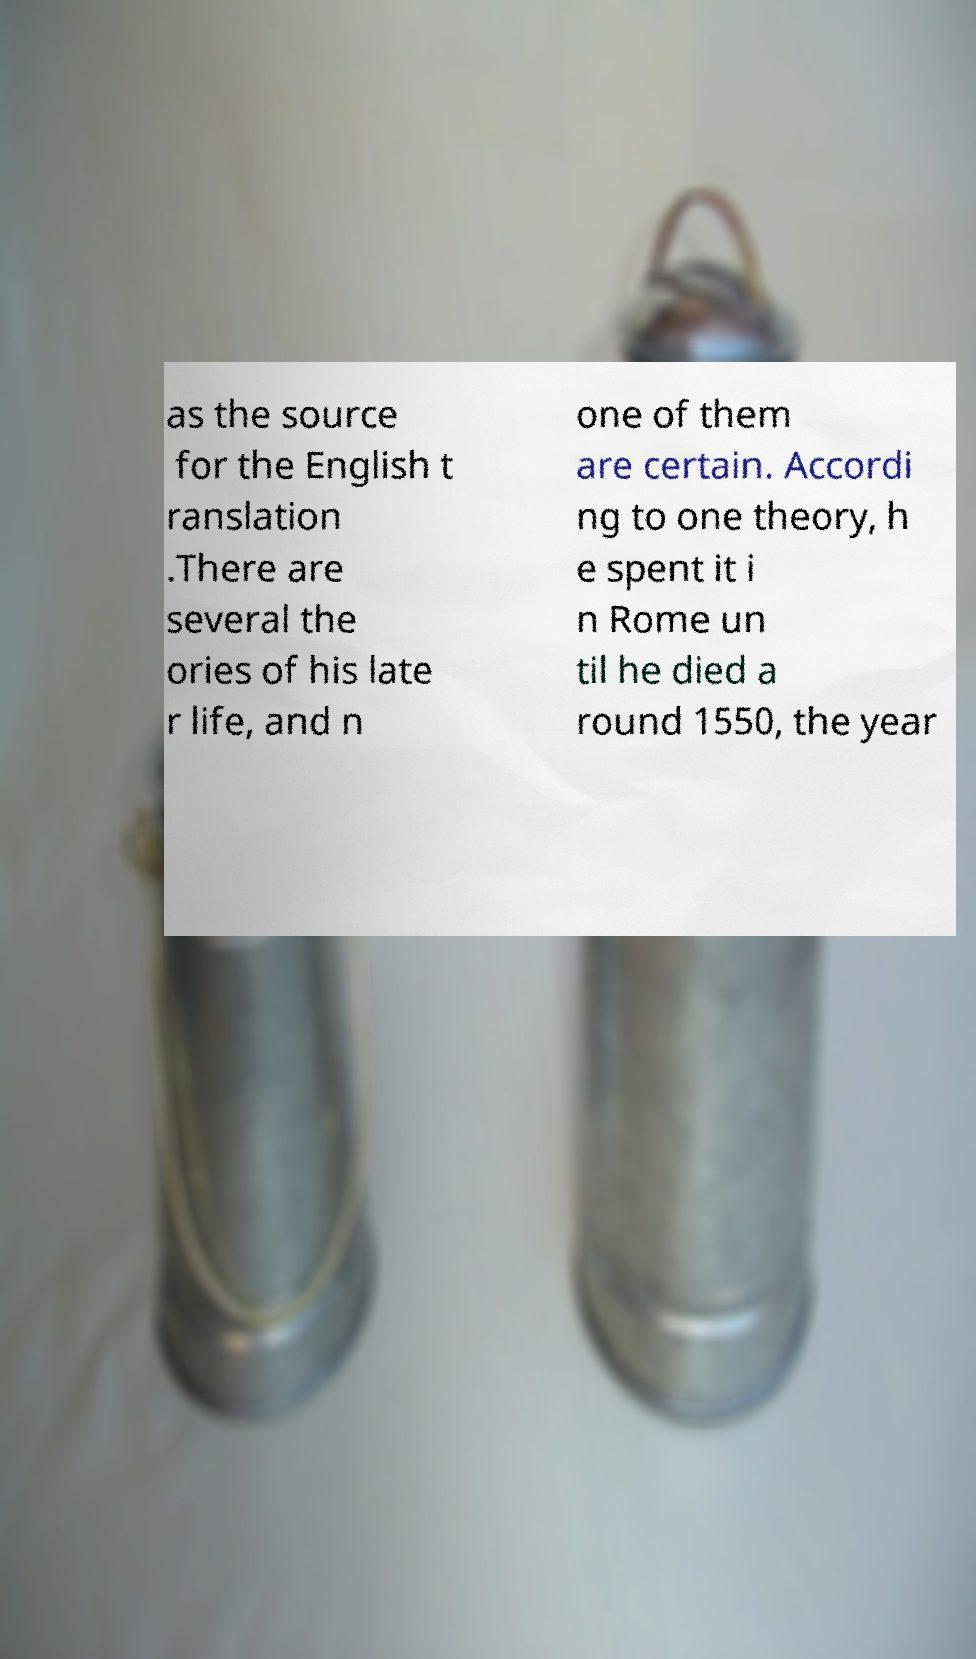Please identify and transcribe the text found in this image. as the source for the English t ranslation .There are several the ories of his late r life, and n one of them are certain. Accordi ng to one theory, h e spent it i n Rome un til he died a round 1550, the year 